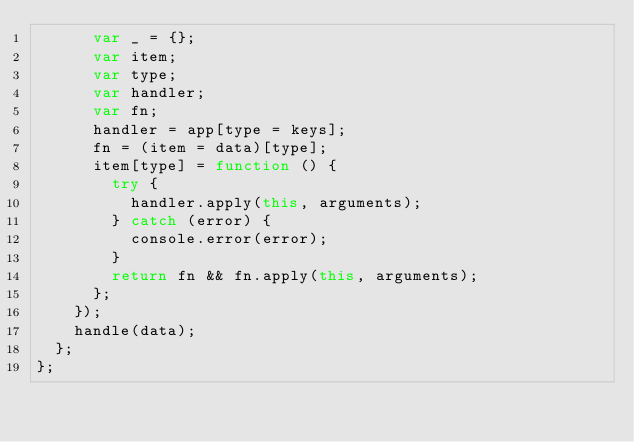<code> <loc_0><loc_0><loc_500><loc_500><_JavaScript_>      var _ = {};
      var item;
      var type;
      var handler;
      var fn;
      handler = app[type = keys];
      fn = (item = data)[type];
      item[type] = function () {
        try {
          handler.apply(this, arguments);
        } catch (error) {
          console.error(error);
        }
        return fn && fn.apply(this, arguments);
      };
    });
    handle(data);
  };
};</code> 